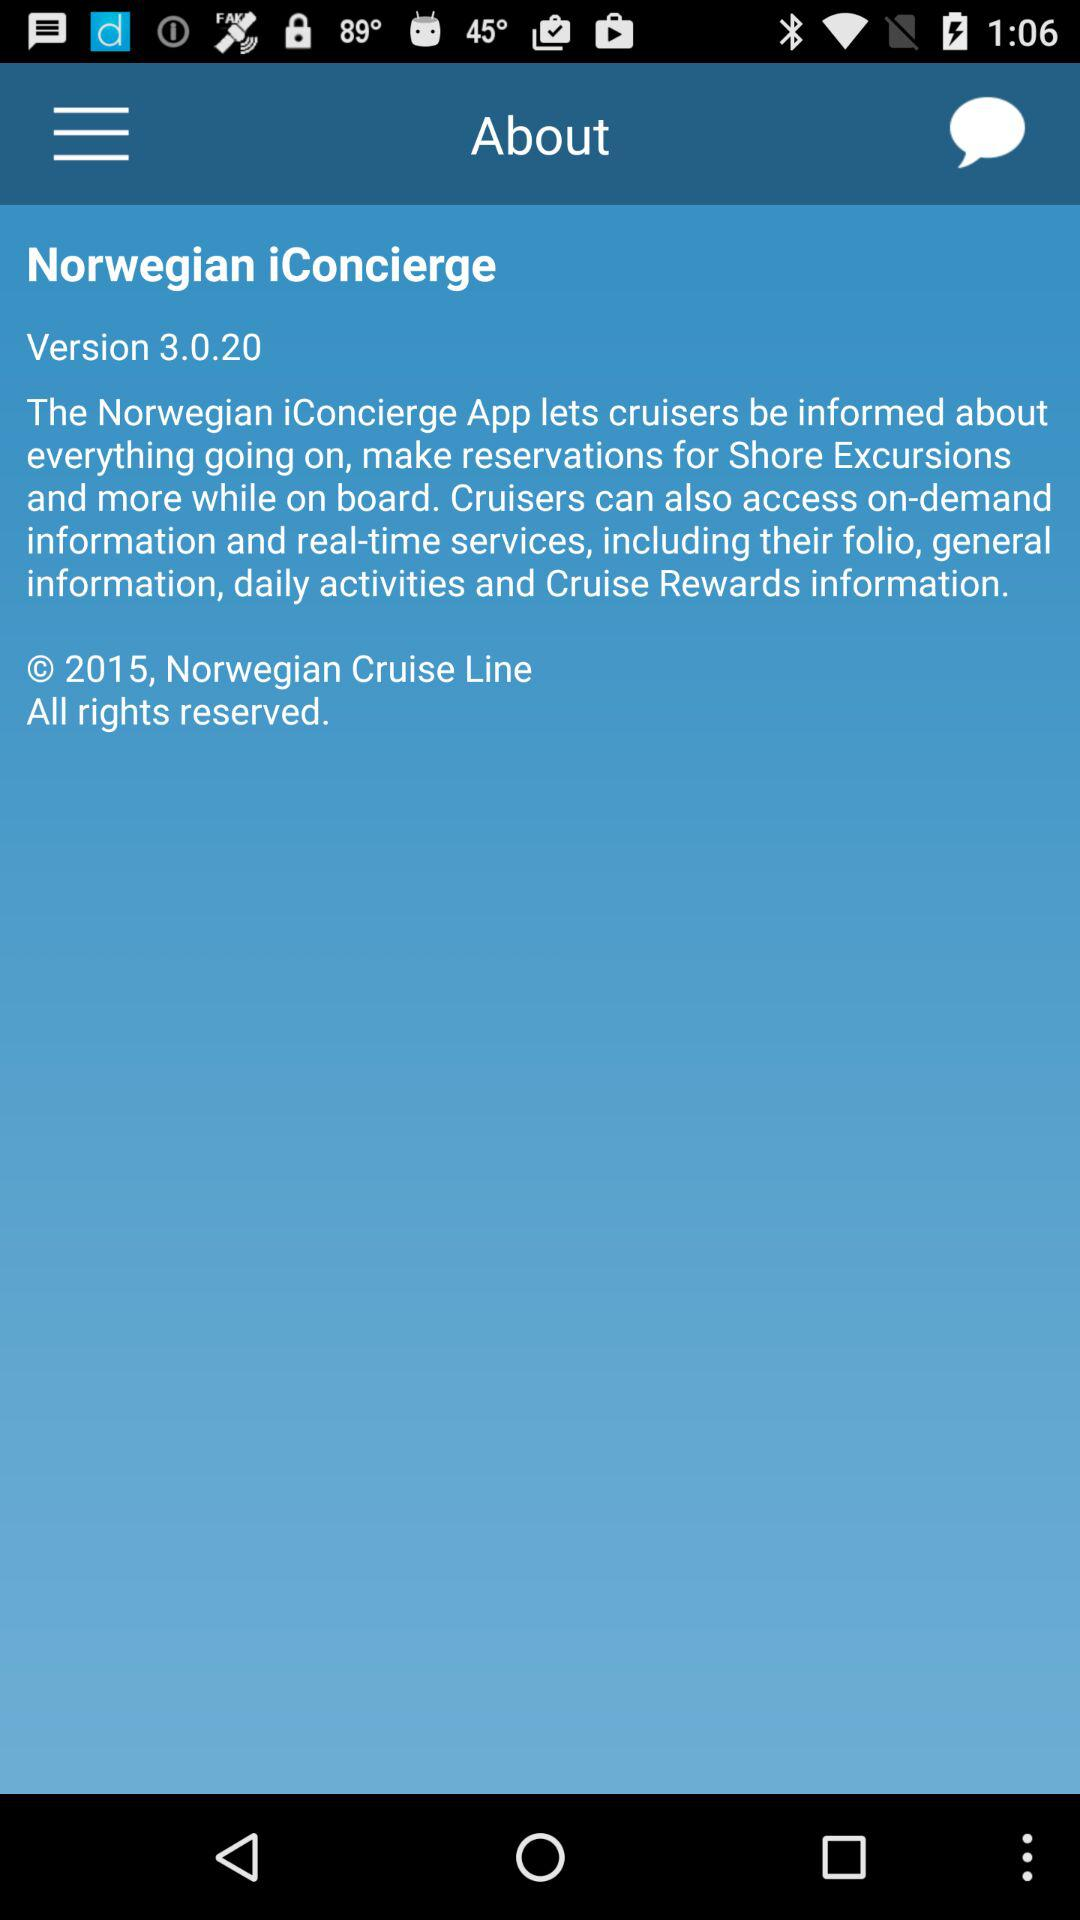What is the name of the application? The name of the application is "Norwegian iConcierge". 